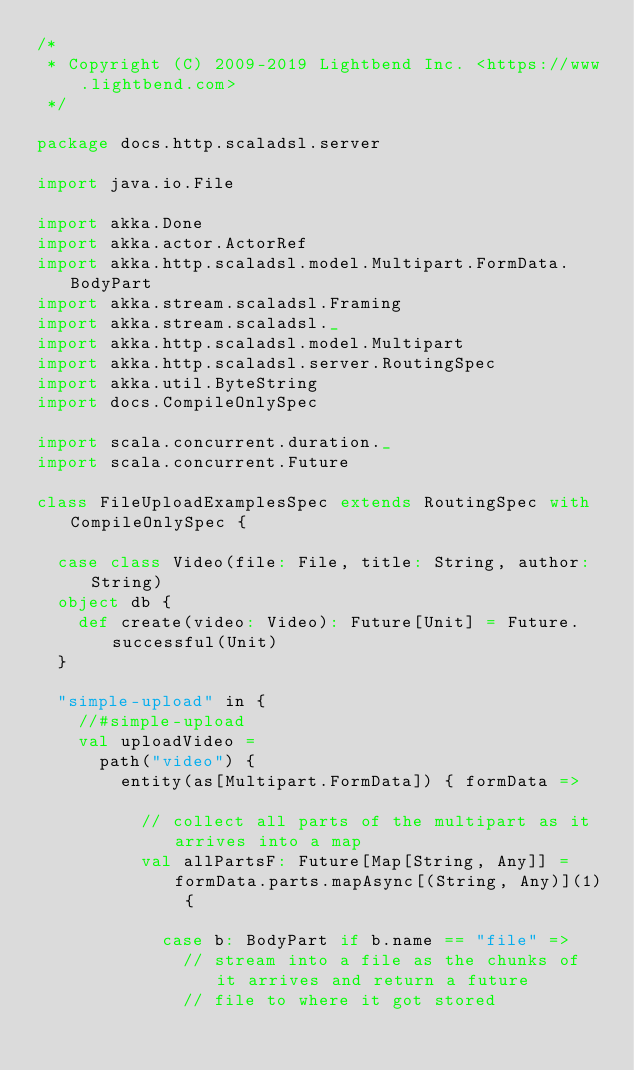Convert code to text. <code><loc_0><loc_0><loc_500><loc_500><_Scala_>/*
 * Copyright (C) 2009-2019 Lightbend Inc. <https://www.lightbend.com>
 */

package docs.http.scaladsl.server

import java.io.File

import akka.Done
import akka.actor.ActorRef
import akka.http.scaladsl.model.Multipart.FormData.BodyPart
import akka.stream.scaladsl.Framing
import akka.stream.scaladsl._
import akka.http.scaladsl.model.Multipart
import akka.http.scaladsl.server.RoutingSpec
import akka.util.ByteString
import docs.CompileOnlySpec

import scala.concurrent.duration._
import scala.concurrent.Future

class FileUploadExamplesSpec extends RoutingSpec with CompileOnlySpec {

  case class Video(file: File, title: String, author: String)
  object db {
    def create(video: Video): Future[Unit] = Future.successful(Unit)
  }

  "simple-upload" in {
    //#simple-upload
    val uploadVideo =
      path("video") {
        entity(as[Multipart.FormData]) { formData =>

          // collect all parts of the multipart as it arrives into a map
          val allPartsF: Future[Map[String, Any]] = formData.parts.mapAsync[(String, Any)](1) {

            case b: BodyPart if b.name == "file" =>
              // stream into a file as the chunks of it arrives and return a future
              // file to where it got stored</code> 